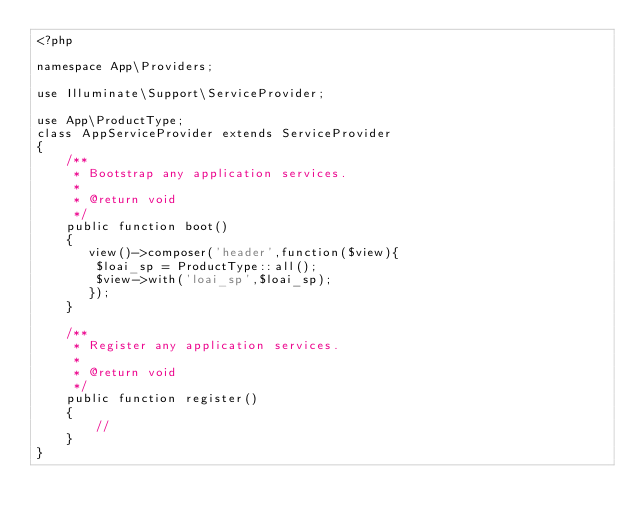Convert code to text. <code><loc_0><loc_0><loc_500><loc_500><_PHP_><?php

namespace App\Providers;

use Illuminate\Support\ServiceProvider;

use App\ProductType;
class AppServiceProvider extends ServiceProvider
{
    /**
     * Bootstrap any application services.
     *
     * @return void
     */
    public function boot()
    {
       view()->composer('header',function($view){
        $loai_sp = ProductType::all();
        $view->with('loai_sp',$loai_sp);
       });
    }

    /**
     * Register any application services.
     *
     * @return void
     */
    public function register()
    {
        //
    }
}
</code> 